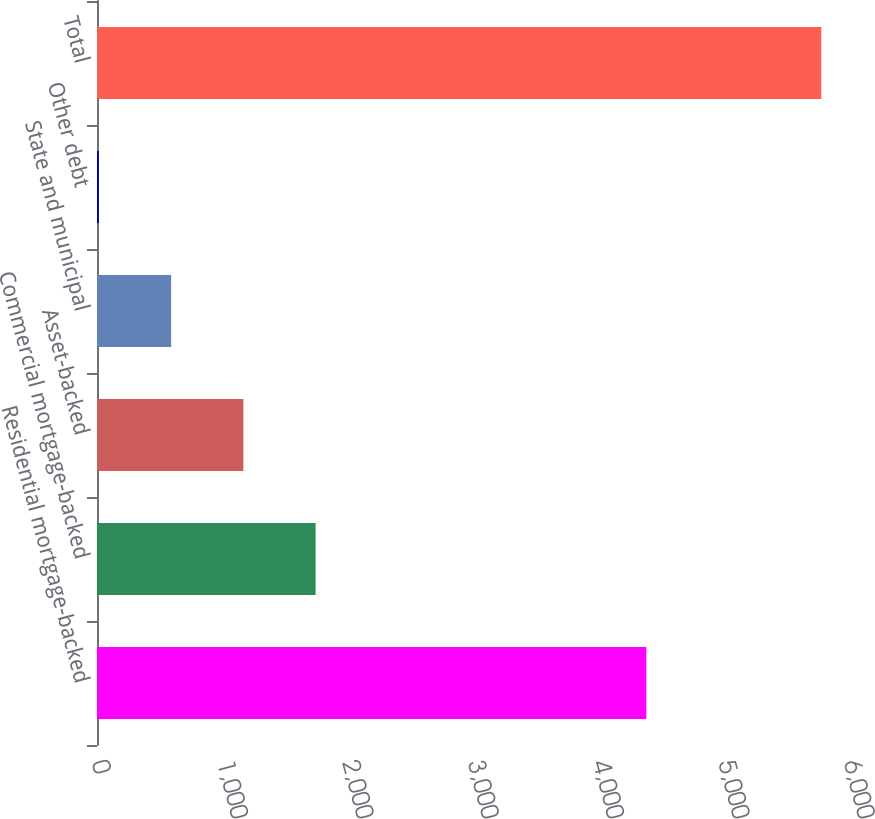Convert chart to OTSL. <chart><loc_0><loc_0><loc_500><loc_500><bar_chart><fcel>Residential mortgage-backed<fcel>Commercial mortgage-backed<fcel>Asset-backed<fcel>State and municipal<fcel>Other debt<fcel>Total<nl><fcel>4383<fcel>1744.2<fcel>1167.8<fcel>591.4<fcel>15<fcel>5779<nl></chart> 